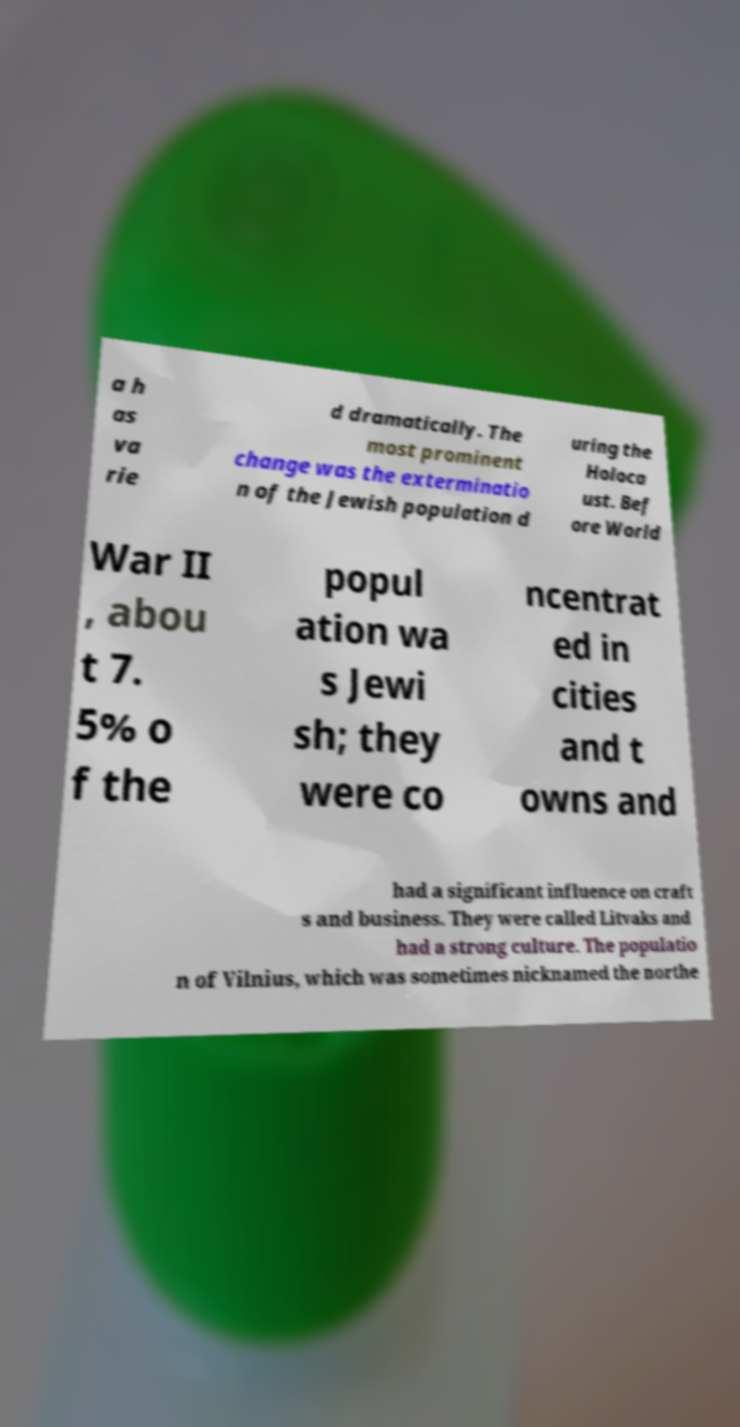What messages or text are displayed in this image? I need them in a readable, typed format. a h as va rie d dramatically. The most prominent change was the exterminatio n of the Jewish population d uring the Holoca ust. Bef ore World War II , abou t 7. 5% o f the popul ation wa s Jewi sh; they were co ncentrat ed in cities and t owns and had a significant influence on craft s and business. They were called Litvaks and had a strong culture. The populatio n of Vilnius, which was sometimes nicknamed the northe 